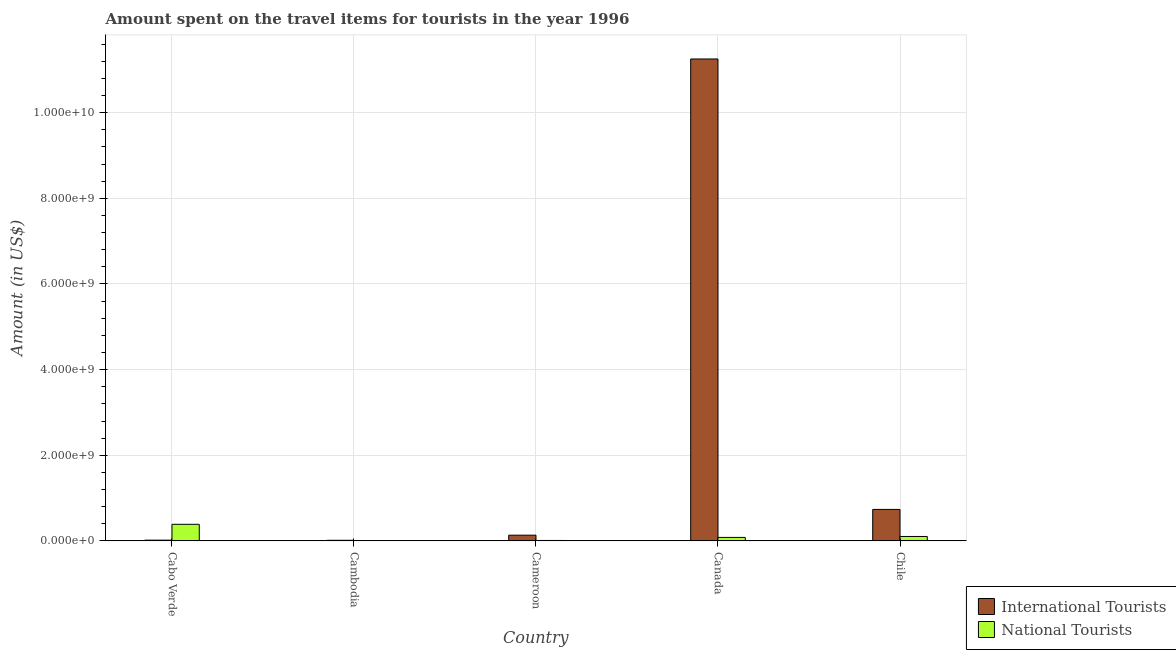How many groups of bars are there?
Provide a short and direct response. 5. Are the number of bars on each tick of the X-axis equal?
Give a very brief answer. Yes. How many bars are there on the 3rd tick from the right?
Ensure brevity in your answer.  2. What is the label of the 1st group of bars from the left?
Offer a terse response. Cabo Verde. What is the amount spent on travel items of international tourists in Cameroon?
Provide a succinct answer. 1.34e+08. Across all countries, what is the maximum amount spent on travel items of national tourists?
Keep it short and to the point. 3.88e+08. Across all countries, what is the minimum amount spent on travel items of national tourists?
Keep it short and to the point. 1.20e+06. In which country was the amount spent on travel items of national tourists maximum?
Ensure brevity in your answer.  Cabo Verde. In which country was the amount spent on travel items of international tourists minimum?
Provide a short and direct response. Cambodia. What is the total amount spent on travel items of national tourists in the graph?
Your answer should be very brief. 5.86e+08. What is the difference between the amount spent on travel items of national tourists in Cambodia and that in Chile?
Make the answer very short. -1.03e+08. What is the difference between the amount spent on travel items of national tourists in Cambodia and the amount spent on travel items of international tourists in Chile?
Your response must be concise. -7.35e+08. What is the average amount spent on travel items of international tourists per country?
Your answer should be very brief. 2.43e+09. What is the difference between the amount spent on travel items of international tourists and amount spent on travel items of national tourists in Cameroon?
Ensure brevity in your answer.  1.23e+08. What is the ratio of the amount spent on travel items of national tourists in Cambodia to that in Canada?
Offer a very short reply. 0.01. Is the difference between the amount spent on travel items of national tourists in Cabo Verde and Canada greater than the difference between the amount spent on travel items of international tourists in Cabo Verde and Canada?
Offer a very short reply. Yes. What is the difference between the highest and the second highest amount spent on travel items of international tourists?
Give a very brief answer. 1.05e+1. What is the difference between the highest and the lowest amount spent on travel items of national tourists?
Your response must be concise. 3.87e+08. Is the sum of the amount spent on travel items of international tourists in Canada and Chile greater than the maximum amount spent on travel items of national tourists across all countries?
Provide a short and direct response. Yes. What does the 2nd bar from the left in Cameroon represents?
Your answer should be very brief. National Tourists. What does the 1st bar from the right in Cambodia represents?
Your answer should be very brief. National Tourists. What is the difference between two consecutive major ticks on the Y-axis?
Provide a succinct answer. 2.00e+09. Does the graph contain any zero values?
Provide a short and direct response. No. Where does the legend appear in the graph?
Provide a short and direct response. Bottom right. How are the legend labels stacked?
Your response must be concise. Vertical. What is the title of the graph?
Your answer should be compact. Amount spent on the travel items for tourists in the year 1996. What is the Amount (in US$) in International Tourists in Cabo Verde?
Make the answer very short. 1.80e+07. What is the Amount (in US$) of National Tourists in Cabo Verde?
Provide a succinct answer. 3.88e+08. What is the Amount (in US$) of International Tourists in Cambodia?
Offer a very short reply. 1.50e+07. What is the Amount (in US$) of National Tourists in Cambodia?
Keep it short and to the point. 1.20e+06. What is the Amount (in US$) of International Tourists in Cameroon?
Your response must be concise. 1.34e+08. What is the Amount (in US$) of National Tourists in Cameroon?
Keep it short and to the point. 1.10e+07. What is the Amount (in US$) of International Tourists in Canada?
Provide a short and direct response. 1.13e+1. What is the Amount (in US$) in National Tourists in Canada?
Your answer should be very brief. 8.20e+07. What is the Amount (in US$) of International Tourists in Chile?
Offer a terse response. 7.36e+08. What is the Amount (in US$) of National Tourists in Chile?
Offer a very short reply. 1.04e+08. Across all countries, what is the maximum Amount (in US$) of International Tourists?
Give a very brief answer. 1.13e+1. Across all countries, what is the maximum Amount (in US$) of National Tourists?
Your response must be concise. 3.88e+08. Across all countries, what is the minimum Amount (in US$) in International Tourists?
Ensure brevity in your answer.  1.50e+07. Across all countries, what is the minimum Amount (in US$) of National Tourists?
Provide a short and direct response. 1.20e+06. What is the total Amount (in US$) of International Tourists in the graph?
Make the answer very short. 1.22e+1. What is the total Amount (in US$) in National Tourists in the graph?
Ensure brevity in your answer.  5.86e+08. What is the difference between the Amount (in US$) of International Tourists in Cabo Verde and that in Cambodia?
Offer a terse response. 3.00e+06. What is the difference between the Amount (in US$) of National Tourists in Cabo Verde and that in Cambodia?
Your answer should be very brief. 3.87e+08. What is the difference between the Amount (in US$) in International Tourists in Cabo Verde and that in Cameroon?
Your answer should be compact. -1.16e+08. What is the difference between the Amount (in US$) of National Tourists in Cabo Verde and that in Cameroon?
Offer a terse response. 3.77e+08. What is the difference between the Amount (in US$) of International Tourists in Cabo Verde and that in Canada?
Provide a short and direct response. -1.12e+1. What is the difference between the Amount (in US$) of National Tourists in Cabo Verde and that in Canada?
Your answer should be compact. 3.06e+08. What is the difference between the Amount (in US$) of International Tourists in Cabo Verde and that in Chile?
Your response must be concise. -7.18e+08. What is the difference between the Amount (in US$) of National Tourists in Cabo Verde and that in Chile?
Your answer should be compact. 2.84e+08. What is the difference between the Amount (in US$) of International Tourists in Cambodia and that in Cameroon?
Your answer should be compact. -1.19e+08. What is the difference between the Amount (in US$) of National Tourists in Cambodia and that in Cameroon?
Provide a succinct answer. -9.80e+06. What is the difference between the Amount (in US$) in International Tourists in Cambodia and that in Canada?
Keep it short and to the point. -1.12e+1. What is the difference between the Amount (in US$) of National Tourists in Cambodia and that in Canada?
Keep it short and to the point. -8.08e+07. What is the difference between the Amount (in US$) of International Tourists in Cambodia and that in Chile?
Provide a succinct answer. -7.21e+08. What is the difference between the Amount (in US$) in National Tourists in Cambodia and that in Chile?
Provide a short and direct response. -1.03e+08. What is the difference between the Amount (in US$) in International Tourists in Cameroon and that in Canada?
Offer a terse response. -1.11e+1. What is the difference between the Amount (in US$) in National Tourists in Cameroon and that in Canada?
Offer a very short reply. -7.10e+07. What is the difference between the Amount (in US$) in International Tourists in Cameroon and that in Chile?
Offer a very short reply. -6.02e+08. What is the difference between the Amount (in US$) in National Tourists in Cameroon and that in Chile?
Your answer should be very brief. -9.30e+07. What is the difference between the Amount (in US$) in International Tourists in Canada and that in Chile?
Provide a succinct answer. 1.05e+1. What is the difference between the Amount (in US$) of National Tourists in Canada and that in Chile?
Ensure brevity in your answer.  -2.20e+07. What is the difference between the Amount (in US$) in International Tourists in Cabo Verde and the Amount (in US$) in National Tourists in Cambodia?
Provide a succinct answer. 1.68e+07. What is the difference between the Amount (in US$) of International Tourists in Cabo Verde and the Amount (in US$) of National Tourists in Cameroon?
Ensure brevity in your answer.  7.00e+06. What is the difference between the Amount (in US$) of International Tourists in Cabo Verde and the Amount (in US$) of National Tourists in Canada?
Keep it short and to the point. -6.40e+07. What is the difference between the Amount (in US$) in International Tourists in Cabo Verde and the Amount (in US$) in National Tourists in Chile?
Provide a short and direct response. -8.60e+07. What is the difference between the Amount (in US$) in International Tourists in Cambodia and the Amount (in US$) in National Tourists in Cameroon?
Your answer should be compact. 4.00e+06. What is the difference between the Amount (in US$) of International Tourists in Cambodia and the Amount (in US$) of National Tourists in Canada?
Give a very brief answer. -6.70e+07. What is the difference between the Amount (in US$) of International Tourists in Cambodia and the Amount (in US$) of National Tourists in Chile?
Give a very brief answer. -8.90e+07. What is the difference between the Amount (in US$) in International Tourists in Cameroon and the Amount (in US$) in National Tourists in Canada?
Offer a terse response. 5.20e+07. What is the difference between the Amount (in US$) of International Tourists in Cameroon and the Amount (in US$) of National Tourists in Chile?
Make the answer very short. 3.00e+07. What is the difference between the Amount (in US$) in International Tourists in Canada and the Amount (in US$) in National Tourists in Chile?
Ensure brevity in your answer.  1.12e+1. What is the average Amount (in US$) of International Tourists per country?
Your response must be concise. 2.43e+09. What is the average Amount (in US$) in National Tourists per country?
Provide a short and direct response. 1.17e+08. What is the difference between the Amount (in US$) in International Tourists and Amount (in US$) in National Tourists in Cabo Verde?
Provide a succinct answer. -3.70e+08. What is the difference between the Amount (in US$) in International Tourists and Amount (in US$) in National Tourists in Cambodia?
Your answer should be very brief. 1.38e+07. What is the difference between the Amount (in US$) in International Tourists and Amount (in US$) in National Tourists in Cameroon?
Your answer should be very brief. 1.23e+08. What is the difference between the Amount (in US$) in International Tourists and Amount (in US$) in National Tourists in Canada?
Offer a terse response. 1.12e+1. What is the difference between the Amount (in US$) of International Tourists and Amount (in US$) of National Tourists in Chile?
Provide a short and direct response. 6.32e+08. What is the ratio of the Amount (in US$) of International Tourists in Cabo Verde to that in Cambodia?
Give a very brief answer. 1.2. What is the ratio of the Amount (in US$) of National Tourists in Cabo Verde to that in Cambodia?
Provide a short and direct response. 323.33. What is the ratio of the Amount (in US$) in International Tourists in Cabo Verde to that in Cameroon?
Offer a very short reply. 0.13. What is the ratio of the Amount (in US$) in National Tourists in Cabo Verde to that in Cameroon?
Offer a terse response. 35.27. What is the ratio of the Amount (in US$) in International Tourists in Cabo Verde to that in Canada?
Your response must be concise. 0. What is the ratio of the Amount (in US$) in National Tourists in Cabo Verde to that in Canada?
Provide a succinct answer. 4.73. What is the ratio of the Amount (in US$) of International Tourists in Cabo Verde to that in Chile?
Your answer should be very brief. 0.02. What is the ratio of the Amount (in US$) in National Tourists in Cabo Verde to that in Chile?
Keep it short and to the point. 3.73. What is the ratio of the Amount (in US$) in International Tourists in Cambodia to that in Cameroon?
Your response must be concise. 0.11. What is the ratio of the Amount (in US$) in National Tourists in Cambodia to that in Cameroon?
Offer a very short reply. 0.11. What is the ratio of the Amount (in US$) in International Tourists in Cambodia to that in Canada?
Give a very brief answer. 0. What is the ratio of the Amount (in US$) in National Tourists in Cambodia to that in Canada?
Make the answer very short. 0.01. What is the ratio of the Amount (in US$) of International Tourists in Cambodia to that in Chile?
Your answer should be compact. 0.02. What is the ratio of the Amount (in US$) in National Tourists in Cambodia to that in Chile?
Your answer should be very brief. 0.01. What is the ratio of the Amount (in US$) in International Tourists in Cameroon to that in Canada?
Give a very brief answer. 0.01. What is the ratio of the Amount (in US$) in National Tourists in Cameroon to that in Canada?
Offer a very short reply. 0.13. What is the ratio of the Amount (in US$) in International Tourists in Cameroon to that in Chile?
Give a very brief answer. 0.18. What is the ratio of the Amount (in US$) in National Tourists in Cameroon to that in Chile?
Keep it short and to the point. 0.11. What is the ratio of the Amount (in US$) of International Tourists in Canada to that in Chile?
Provide a succinct answer. 15.29. What is the ratio of the Amount (in US$) of National Tourists in Canada to that in Chile?
Your response must be concise. 0.79. What is the difference between the highest and the second highest Amount (in US$) in International Tourists?
Your response must be concise. 1.05e+1. What is the difference between the highest and the second highest Amount (in US$) in National Tourists?
Ensure brevity in your answer.  2.84e+08. What is the difference between the highest and the lowest Amount (in US$) of International Tourists?
Your response must be concise. 1.12e+1. What is the difference between the highest and the lowest Amount (in US$) in National Tourists?
Ensure brevity in your answer.  3.87e+08. 